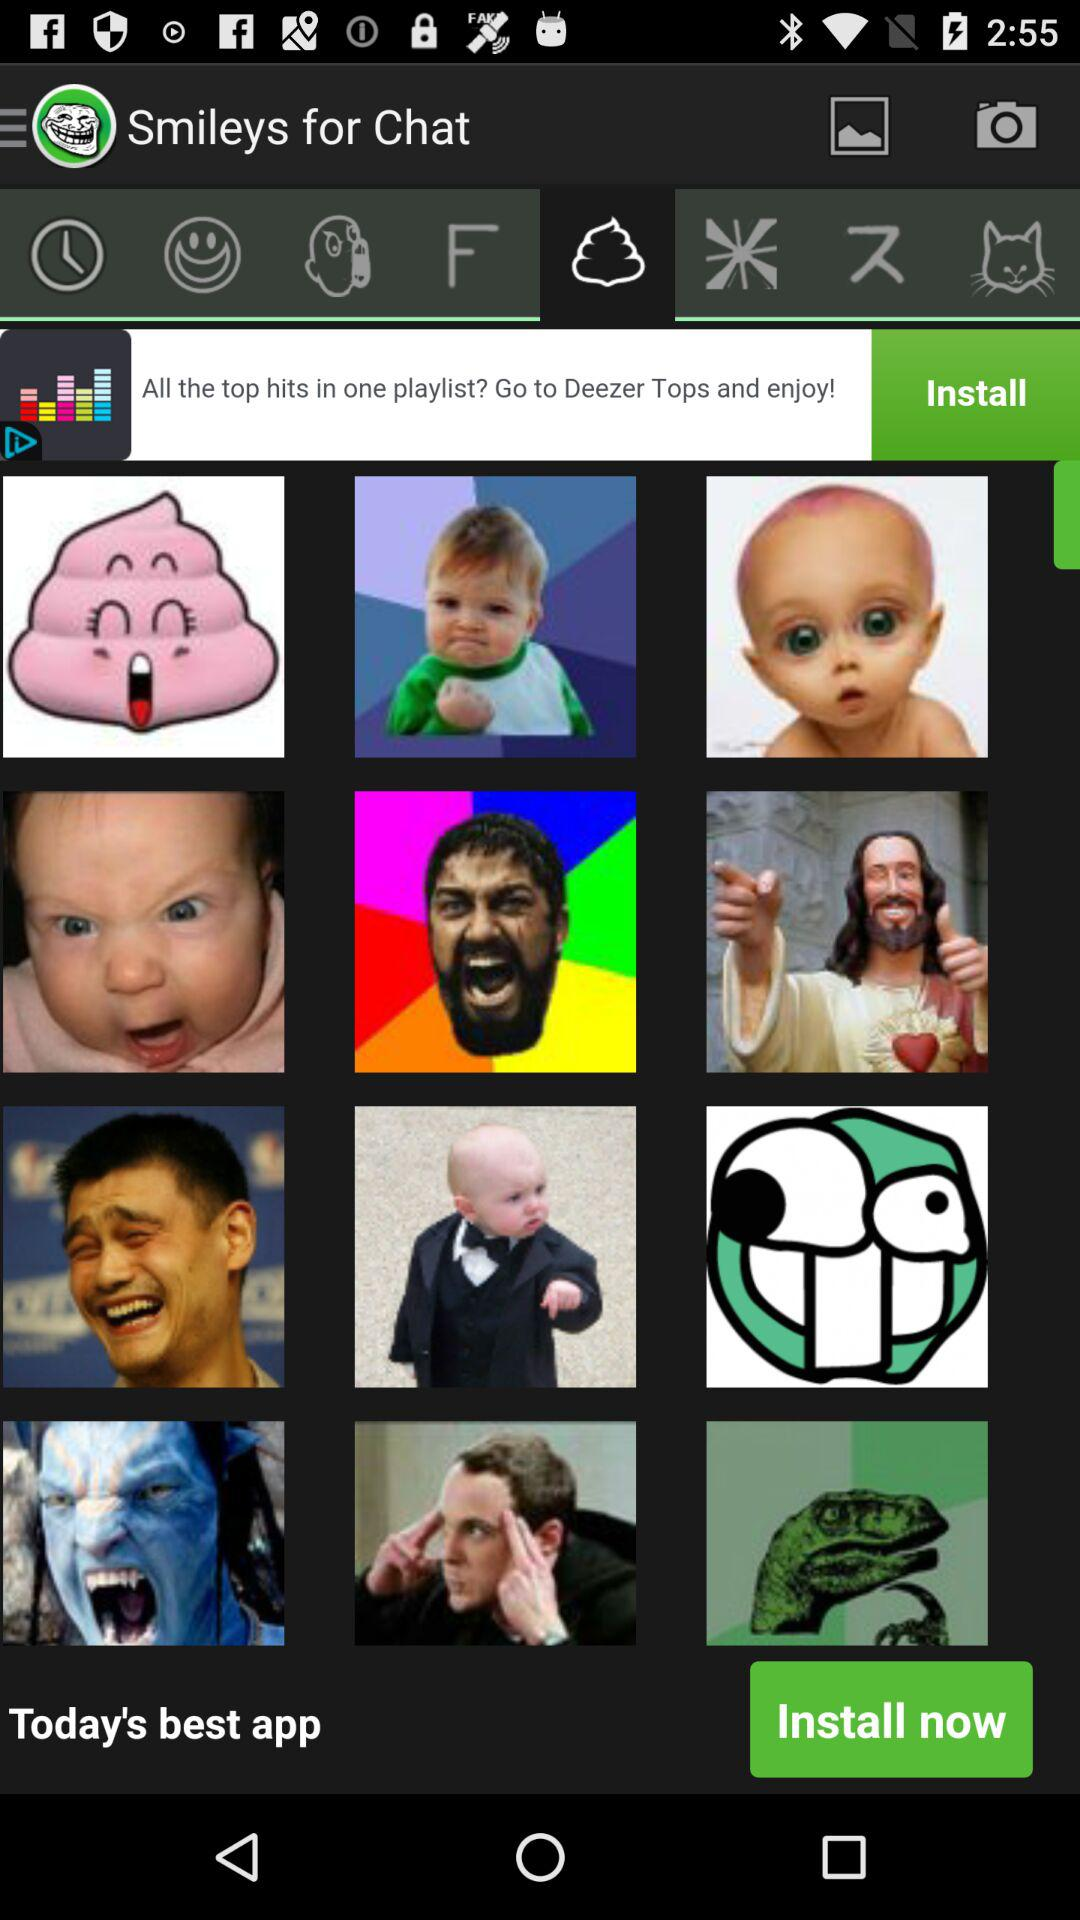How many ratings does "Smileys for Chat" have?
When the provided information is insufficient, respond with <no answer>. <no answer> 